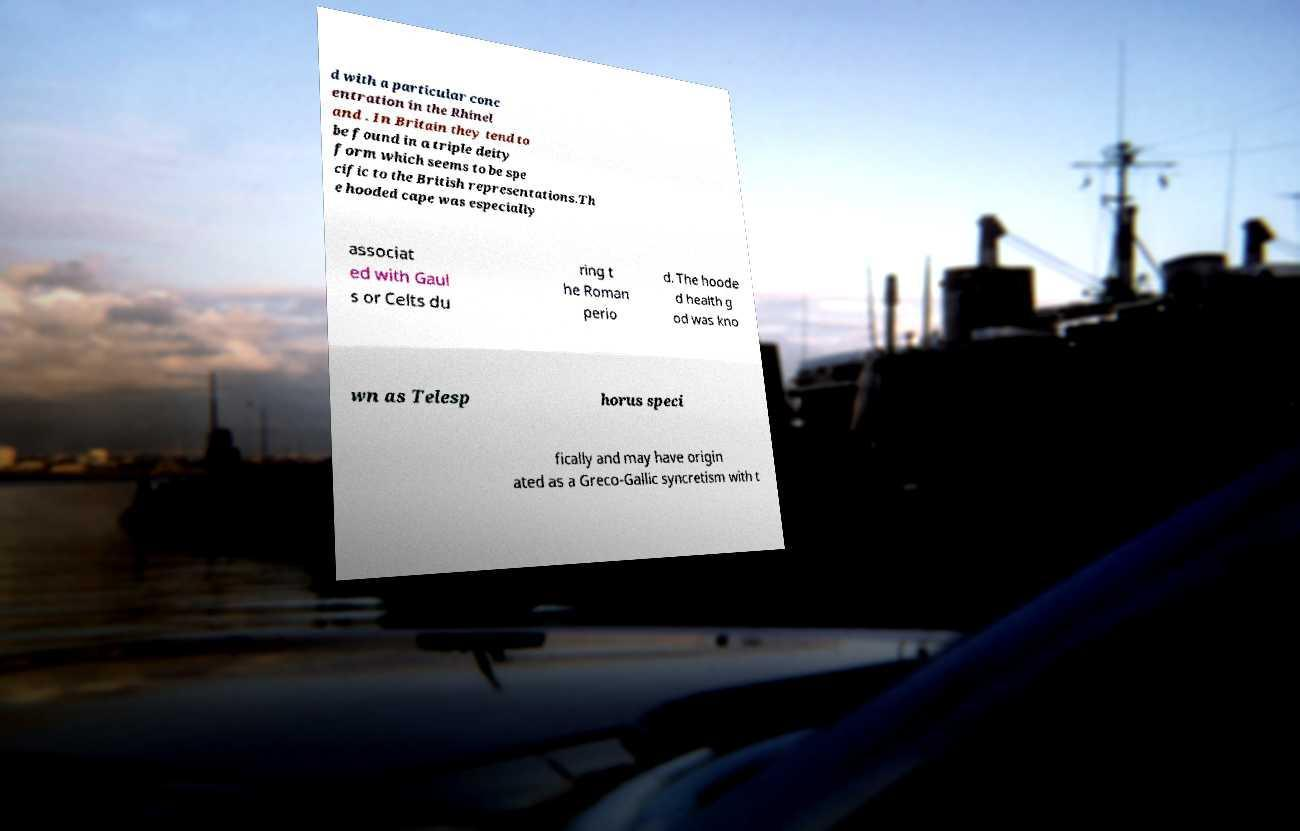Please identify and transcribe the text found in this image. d with a particular conc entration in the Rhinel and . In Britain they tend to be found in a triple deity form which seems to be spe cific to the British representations.Th e hooded cape was especially associat ed with Gaul s or Celts du ring t he Roman perio d. The hoode d health g od was kno wn as Telesp horus speci fically and may have origin ated as a Greco-Gallic syncretism with t 